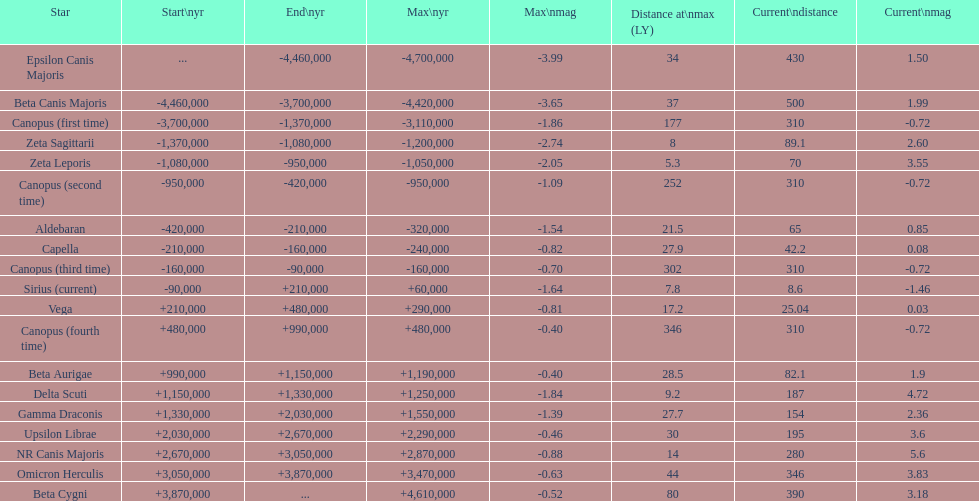How many stars do not have a current magnitude greater than zero? 5. 